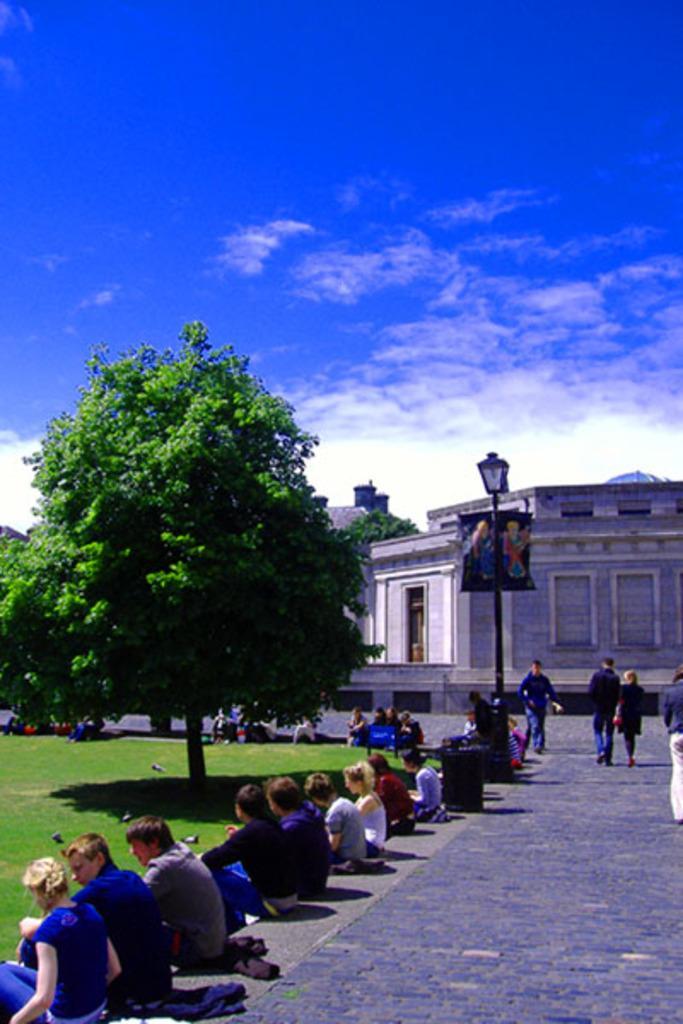Can you describe this image briefly? This image is taken outdoors. At the top of the image there is the sky with clouds. At the bottom of the image there is floor. In the background there is a building with walls, windows, a door and a roof. There is a pole with a street light. There are a few trees. On the right side of the image a few people are walking on the floor. On the left side of the image there is a ground with grass on it and there is a tree. Many people are sitting on the floor. 